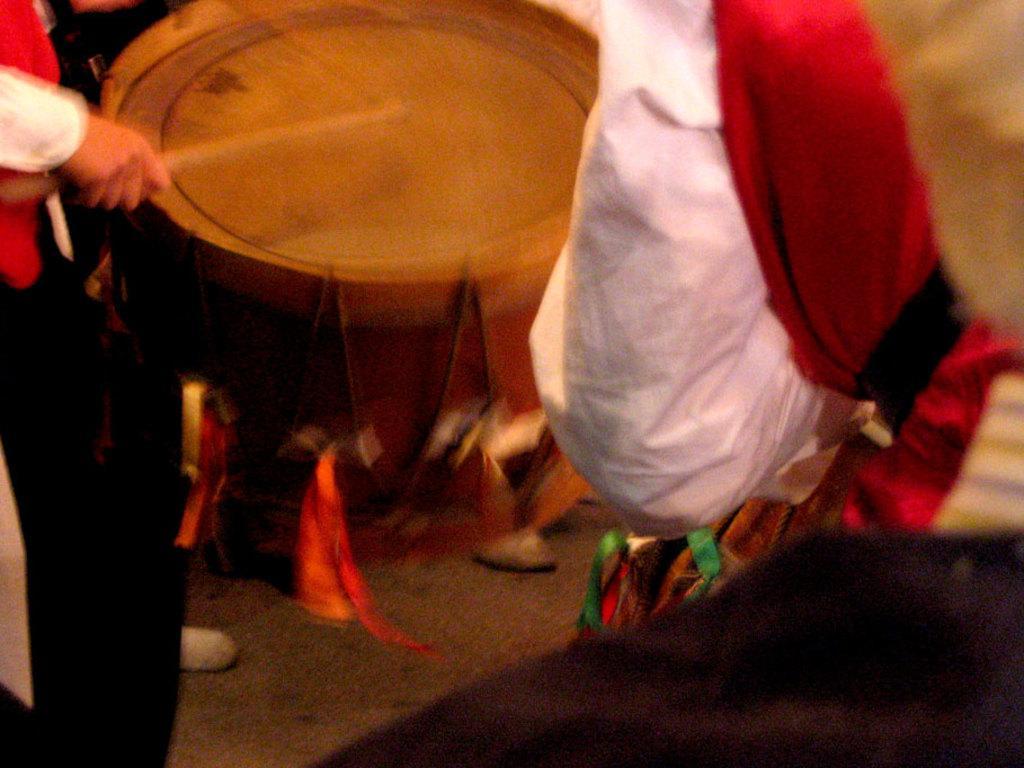Could you give a brief overview of what you see in this image? In this picture we can observe a person playing a drum, holding a stick in his hand. On the right side we can observe a person standing. The background is blurred. 